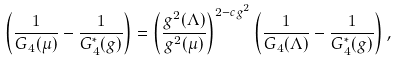Convert formula to latex. <formula><loc_0><loc_0><loc_500><loc_500>\left ( \frac { 1 } { G _ { 4 } ( \mu ) } - \frac { 1 } { G _ { 4 } ^ { * } ( g ) } \right ) = \left ( \frac { g ^ { 2 } ( \Lambda ) } { g ^ { 2 } ( \mu ) } \right ) ^ { 2 - c g ^ { 2 } } \left ( \frac { 1 } { G _ { 4 } ( \Lambda ) } - \frac { 1 } { G _ { 4 } ^ { * } ( g ) } \right ) ,</formula> 